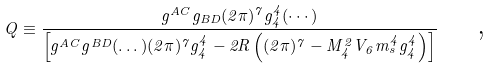<formula> <loc_0><loc_0><loc_500><loc_500>Q \equiv \frac { g ^ { A C } g _ { B D } ( 2 \pi ) ^ { 7 } g _ { 4 } ^ { 4 } ( \cdots ) } { \left [ g ^ { A C } g ^ { B D } ( \dots ) ( 2 \pi ) ^ { 7 } g _ { 4 } ^ { 4 } - 2 R \left ( ( 2 \pi ) ^ { 7 } - M _ { 4 } ^ { 2 } V _ { 6 } m _ { s } ^ { 4 } g _ { 4 } ^ { 4 } \right ) \right ] } \text { \quad ,}</formula> 